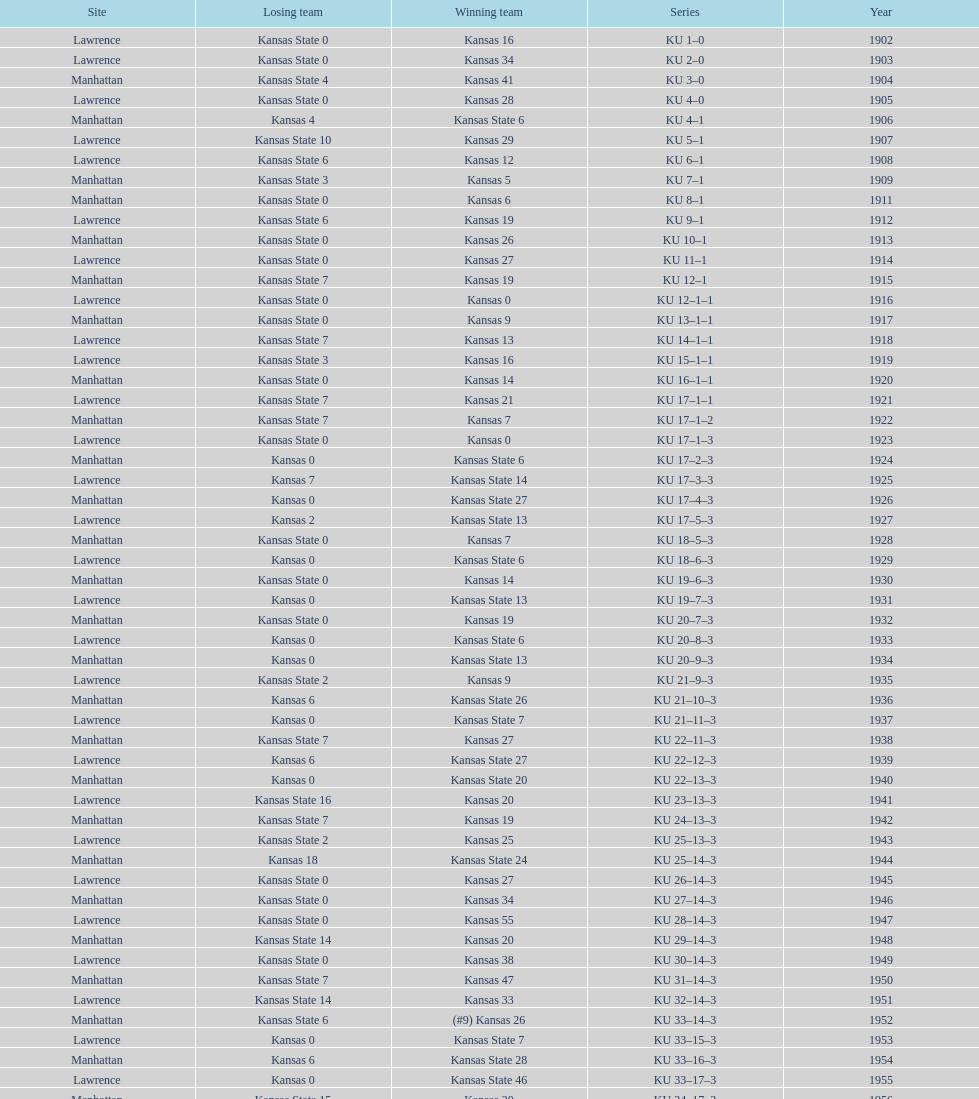How many times did kansas beat kansas state before 1910? 7. 